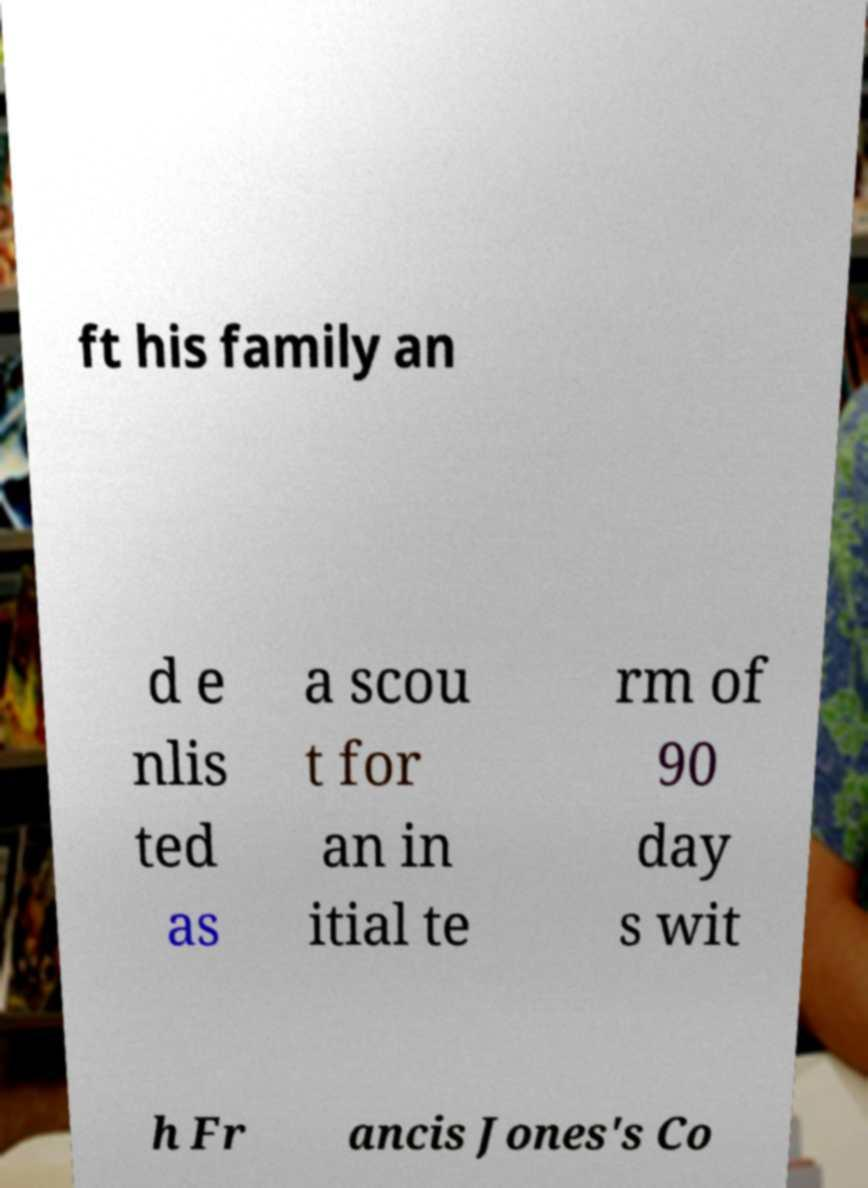Could you extract and type out the text from this image? ft his family an d e nlis ted as a scou t for an in itial te rm of 90 day s wit h Fr ancis Jones's Co 